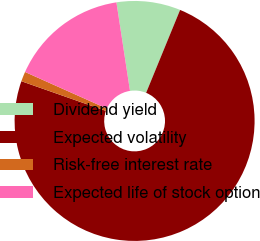<chart> <loc_0><loc_0><loc_500><loc_500><pie_chart><fcel>Dividend yield<fcel>Expected volatility<fcel>Risk-free interest rate<fcel>Expected life of stock option<nl><fcel>8.61%<fcel>74.18%<fcel>1.32%<fcel>15.89%<nl></chart> 